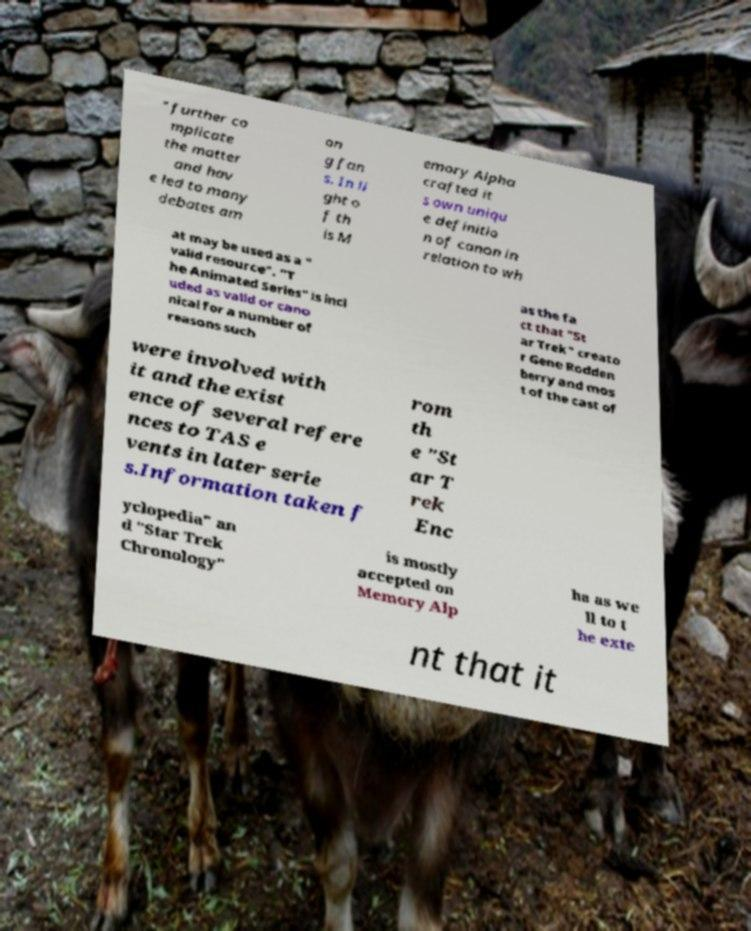Could you assist in decoding the text presented in this image and type it out clearly? " further co mplicate the matter and hav e led to many debates am on g fan s. In li ght o f th is M emory Alpha crafted it s own uniqu e definitio n of canon in relation to wh at may be used as a " valid resource". "T he Animated Series" is incl uded as valid or cano nical for a number of reasons such as the fa ct that "St ar Trek" creato r Gene Rodden berry and mos t of the cast of were involved with it and the exist ence of several refere nces to TAS e vents in later serie s.Information taken f rom th e "St ar T rek Enc yclopedia" an d "Star Trek Chronology" is mostly accepted on Memory Alp ha as we ll to t he exte nt that it 